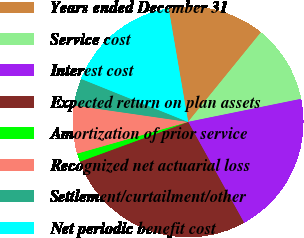Convert chart to OTSL. <chart><loc_0><loc_0><loc_500><loc_500><pie_chart><fcel>Years ended December 31<fcel>Service cost<fcel>Interest cost<fcel>Expected return on plan assets<fcel>Amortization of prior service<fcel>Recognized net actuarial loss<fcel>Settlement/curtailment/other<fcel>Net periodic benefit cost<nl><fcel>13.57%<fcel>10.94%<fcel>20.14%<fcel>27.46%<fcel>1.17%<fcel>6.72%<fcel>3.8%<fcel>16.2%<nl></chart> 